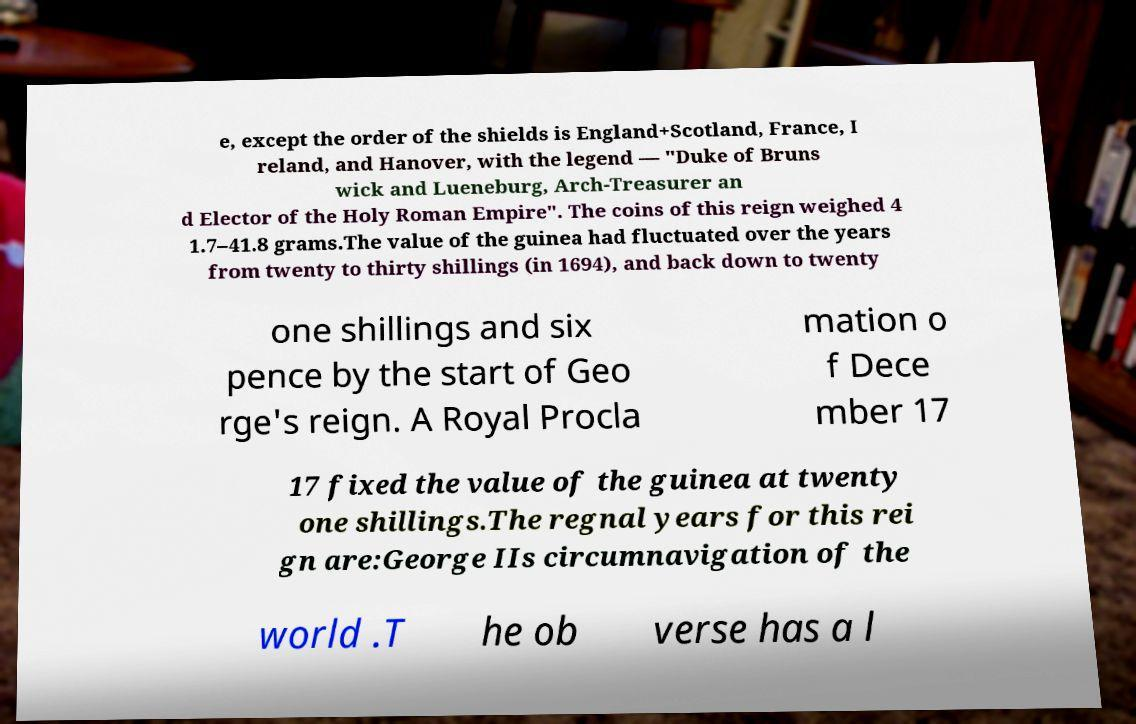What messages or text are displayed in this image? I need them in a readable, typed format. e, except the order of the shields is England+Scotland, France, I reland, and Hanover, with the legend — "Duke of Bruns wick and Lueneburg, Arch-Treasurer an d Elector of the Holy Roman Empire". The coins of this reign weighed 4 1.7–41.8 grams.The value of the guinea had fluctuated over the years from twenty to thirty shillings (in 1694), and back down to twenty one shillings and six pence by the start of Geo rge's reign. A Royal Procla mation o f Dece mber 17 17 fixed the value of the guinea at twenty one shillings.The regnal years for this rei gn are:George IIs circumnavigation of the world .T he ob verse has a l 